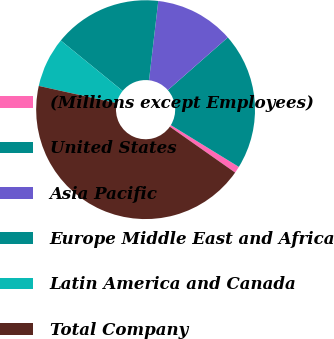Convert chart. <chart><loc_0><loc_0><loc_500><loc_500><pie_chart><fcel>(Millions except Employees)<fcel>United States<fcel>Asia Pacific<fcel>Europe Middle East and Africa<fcel>Latin America and Canada<fcel>Total Company<nl><fcel>0.99%<fcel>20.23%<fcel>11.68%<fcel>15.96%<fcel>7.41%<fcel>43.73%<nl></chart> 